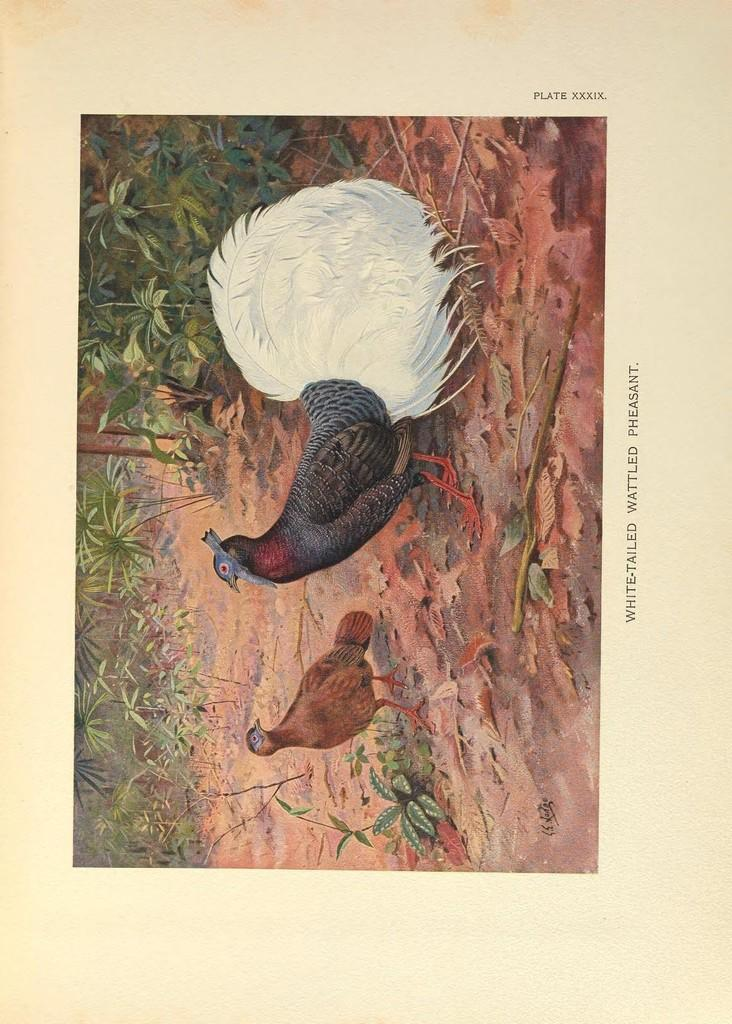What is located in the foreground of the image? There is a poster in the foreground of the image. What type of natural environment can be seen in the image? Greenery is visible in the image. What type of animals are present in the image? Birds are present in the image. What type of chain can be seen connecting the birds in the image? There is no chain present in the image; the birds are not connected. 